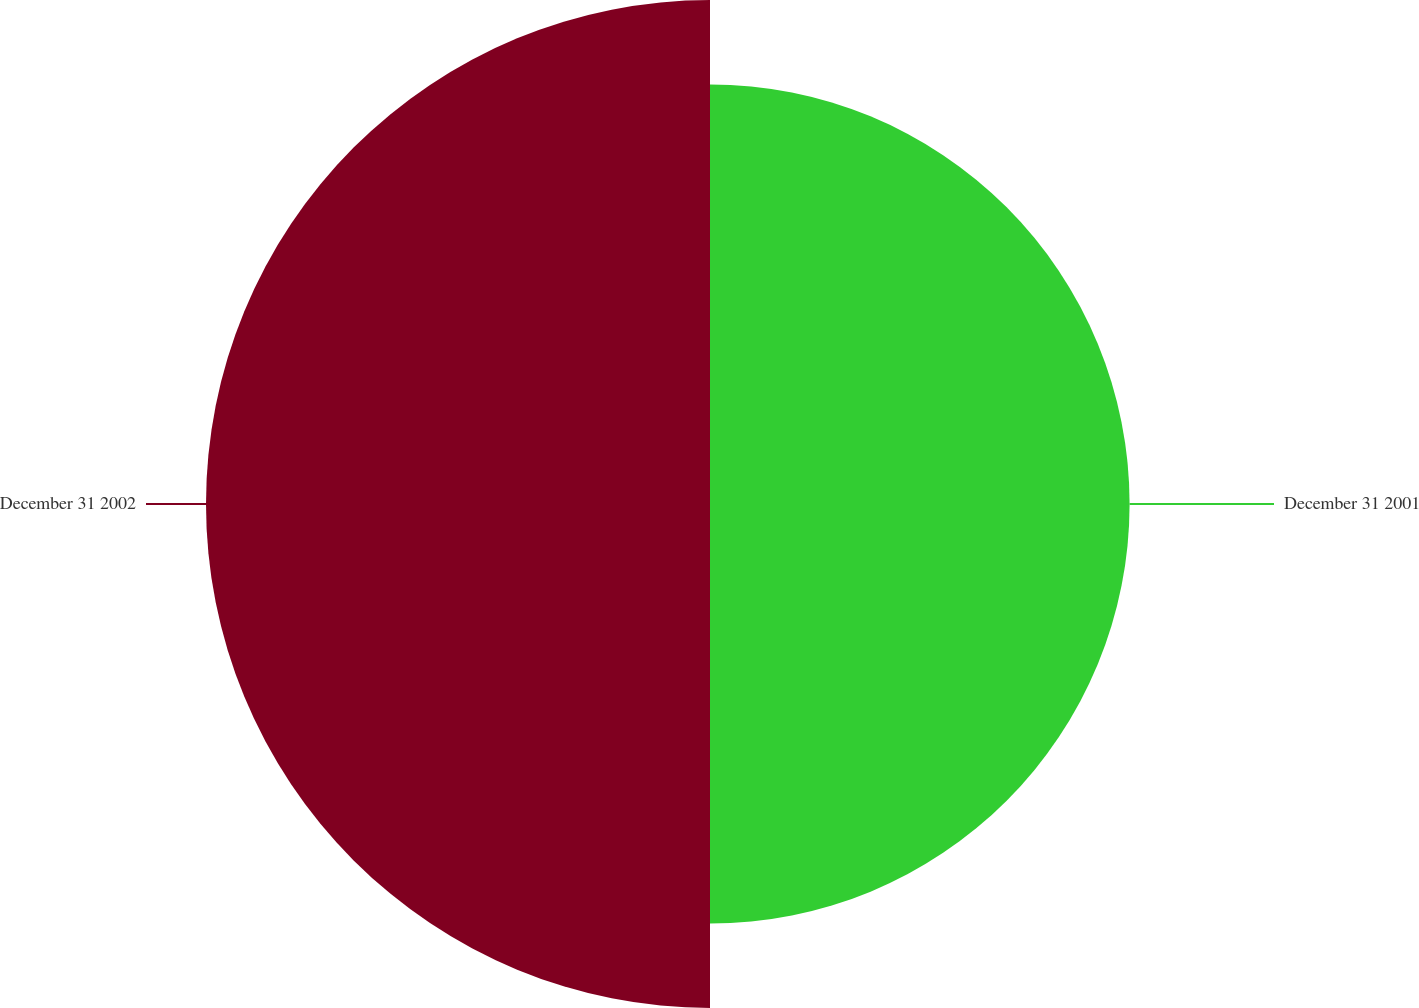<chart> <loc_0><loc_0><loc_500><loc_500><pie_chart><fcel>December 31 2001<fcel>December 31 2002<nl><fcel>45.43%<fcel>54.57%<nl></chart> 